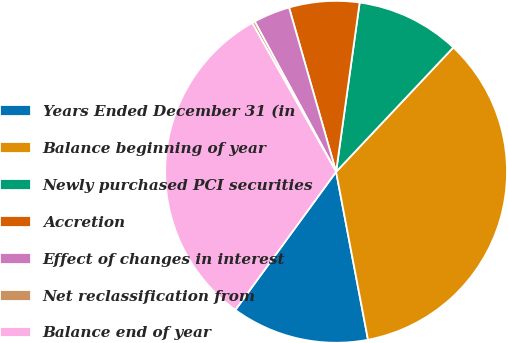<chart> <loc_0><loc_0><loc_500><loc_500><pie_chart><fcel>Years Ended December 31 (in<fcel>Balance beginning of year<fcel>Newly purchased PCI securities<fcel>Accretion<fcel>Effect of changes in interest<fcel>Net reclassification from<fcel>Balance end of year<nl><fcel>13.02%<fcel>34.98%<fcel>9.83%<fcel>6.64%<fcel>3.46%<fcel>0.27%<fcel>31.8%<nl></chart> 